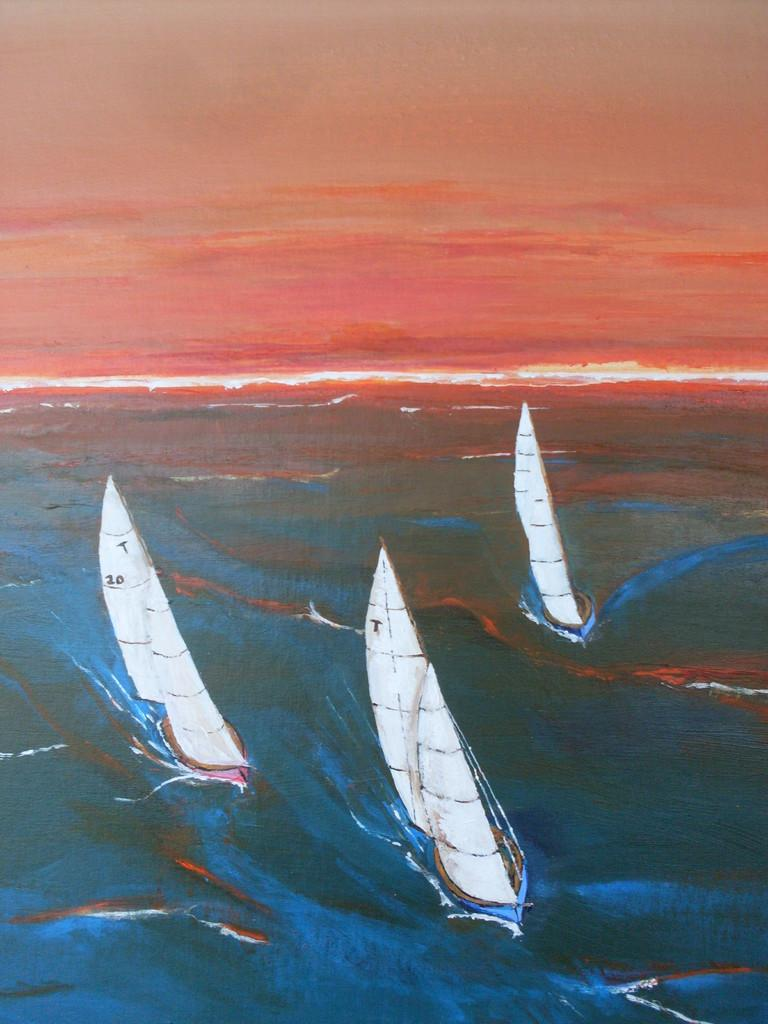<image>
Describe the image concisely. the sails on the boat are white and going through rough water 